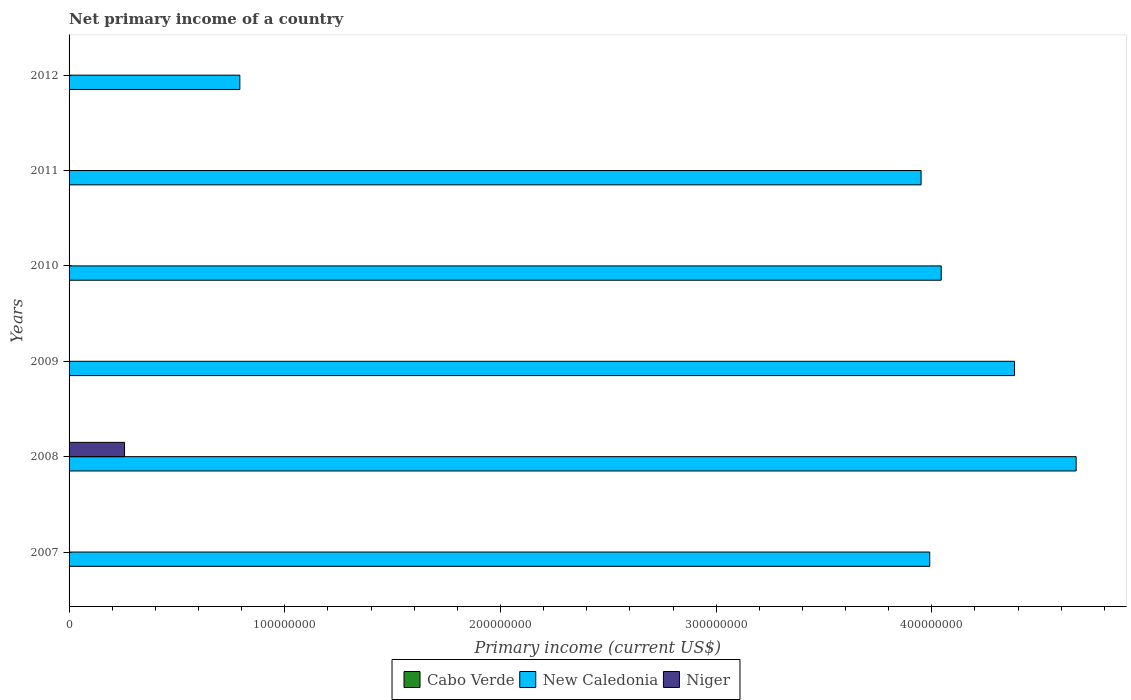Are the number of bars on each tick of the Y-axis equal?
Your response must be concise. No. How many bars are there on the 6th tick from the top?
Offer a terse response. 1. How many bars are there on the 1st tick from the bottom?
Offer a terse response. 1. In how many cases, is the number of bars for a given year not equal to the number of legend labels?
Keep it short and to the point. 6. What is the primary income in New Caledonia in 2012?
Offer a terse response. 7.92e+07. Across all years, what is the maximum primary income in Niger?
Offer a terse response. 2.57e+07. Across all years, what is the minimum primary income in New Caledonia?
Provide a short and direct response. 7.92e+07. What is the total primary income in New Caledonia in the graph?
Make the answer very short. 2.18e+09. What is the difference between the primary income in New Caledonia in 2007 and that in 2010?
Your answer should be very brief. -5.32e+06. What is the difference between the primary income in New Caledonia in 2008 and the primary income in Niger in 2012?
Your response must be concise. 4.67e+08. What is the difference between the highest and the second highest primary income in New Caledonia?
Your answer should be compact. 2.86e+07. What is the difference between the highest and the lowest primary income in New Caledonia?
Make the answer very short. 3.88e+08. Is the sum of the primary income in New Caledonia in 2008 and 2010 greater than the maximum primary income in Cabo Verde across all years?
Make the answer very short. Yes. Are all the bars in the graph horizontal?
Your response must be concise. Yes. Are the values on the major ticks of X-axis written in scientific E-notation?
Your answer should be very brief. No. Does the graph contain grids?
Ensure brevity in your answer.  No. How are the legend labels stacked?
Your answer should be compact. Horizontal. What is the title of the graph?
Provide a short and direct response. Net primary income of a country. What is the label or title of the X-axis?
Your response must be concise. Primary income (current US$). What is the label or title of the Y-axis?
Keep it short and to the point. Years. What is the Primary income (current US$) in New Caledonia in 2007?
Make the answer very short. 3.99e+08. What is the Primary income (current US$) in Niger in 2007?
Offer a terse response. 0. What is the Primary income (current US$) of New Caledonia in 2008?
Provide a short and direct response. 4.67e+08. What is the Primary income (current US$) of Niger in 2008?
Ensure brevity in your answer.  2.57e+07. What is the Primary income (current US$) of Cabo Verde in 2009?
Keep it short and to the point. 0. What is the Primary income (current US$) of New Caledonia in 2009?
Your answer should be compact. 4.38e+08. What is the Primary income (current US$) in Niger in 2009?
Your answer should be very brief. 0. What is the Primary income (current US$) of New Caledonia in 2010?
Keep it short and to the point. 4.04e+08. What is the Primary income (current US$) of Niger in 2010?
Provide a short and direct response. 0. What is the Primary income (current US$) in Cabo Verde in 2011?
Keep it short and to the point. 0. What is the Primary income (current US$) in New Caledonia in 2011?
Provide a short and direct response. 3.95e+08. What is the Primary income (current US$) in Cabo Verde in 2012?
Your response must be concise. 0. What is the Primary income (current US$) of New Caledonia in 2012?
Your answer should be compact. 7.92e+07. What is the Primary income (current US$) in Niger in 2012?
Provide a succinct answer. 0. Across all years, what is the maximum Primary income (current US$) of New Caledonia?
Give a very brief answer. 4.67e+08. Across all years, what is the maximum Primary income (current US$) in Niger?
Ensure brevity in your answer.  2.57e+07. Across all years, what is the minimum Primary income (current US$) in New Caledonia?
Your response must be concise. 7.92e+07. What is the total Primary income (current US$) in New Caledonia in the graph?
Provide a short and direct response. 2.18e+09. What is the total Primary income (current US$) of Niger in the graph?
Provide a succinct answer. 2.57e+07. What is the difference between the Primary income (current US$) in New Caledonia in 2007 and that in 2008?
Offer a terse response. -6.79e+07. What is the difference between the Primary income (current US$) in New Caledonia in 2007 and that in 2009?
Keep it short and to the point. -3.93e+07. What is the difference between the Primary income (current US$) in New Caledonia in 2007 and that in 2010?
Provide a short and direct response. -5.32e+06. What is the difference between the Primary income (current US$) in New Caledonia in 2007 and that in 2011?
Offer a very short reply. 4.02e+06. What is the difference between the Primary income (current US$) in New Caledonia in 2007 and that in 2012?
Your answer should be very brief. 3.20e+08. What is the difference between the Primary income (current US$) of New Caledonia in 2008 and that in 2009?
Your answer should be compact. 2.86e+07. What is the difference between the Primary income (current US$) of New Caledonia in 2008 and that in 2010?
Give a very brief answer. 6.26e+07. What is the difference between the Primary income (current US$) of New Caledonia in 2008 and that in 2011?
Provide a succinct answer. 7.19e+07. What is the difference between the Primary income (current US$) in New Caledonia in 2008 and that in 2012?
Offer a terse response. 3.88e+08. What is the difference between the Primary income (current US$) of New Caledonia in 2009 and that in 2010?
Offer a very short reply. 3.40e+07. What is the difference between the Primary income (current US$) in New Caledonia in 2009 and that in 2011?
Your answer should be very brief. 4.33e+07. What is the difference between the Primary income (current US$) in New Caledonia in 2009 and that in 2012?
Make the answer very short. 3.59e+08. What is the difference between the Primary income (current US$) in New Caledonia in 2010 and that in 2011?
Offer a terse response. 9.33e+06. What is the difference between the Primary income (current US$) in New Caledonia in 2010 and that in 2012?
Make the answer very short. 3.25e+08. What is the difference between the Primary income (current US$) of New Caledonia in 2011 and that in 2012?
Provide a succinct answer. 3.16e+08. What is the difference between the Primary income (current US$) of New Caledonia in 2007 and the Primary income (current US$) of Niger in 2008?
Provide a succinct answer. 3.73e+08. What is the average Primary income (current US$) in Cabo Verde per year?
Provide a short and direct response. 0. What is the average Primary income (current US$) of New Caledonia per year?
Give a very brief answer. 3.64e+08. What is the average Primary income (current US$) of Niger per year?
Make the answer very short. 4.29e+06. In the year 2008, what is the difference between the Primary income (current US$) in New Caledonia and Primary income (current US$) in Niger?
Ensure brevity in your answer.  4.41e+08. What is the ratio of the Primary income (current US$) of New Caledonia in 2007 to that in 2008?
Make the answer very short. 0.85. What is the ratio of the Primary income (current US$) of New Caledonia in 2007 to that in 2009?
Provide a short and direct response. 0.91. What is the ratio of the Primary income (current US$) in New Caledonia in 2007 to that in 2010?
Keep it short and to the point. 0.99. What is the ratio of the Primary income (current US$) of New Caledonia in 2007 to that in 2011?
Offer a very short reply. 1.01. What is the ratio of the Primary income (current US$) of New Caledonia in 2007 to that in 2012?
Ensure brevity in your answer.  5.04. What is the ratio of the Primary income (current US$) of New Caledonia in 2008 to that in 2009?
Give a very brief answer. 1.07. What is the ratio of the Primary income (current US$) in New Caledonia in 2008 to that in 2010?
Give a very brief answer. 1.15. What is the ratio of the Primary income (current US$) of New Caledonia in 2008 to that in 2011?
Make the answer very short. 1.18. What is the ratio of the Primary income (current US$) of New Caledonia in 2008 to that in 2012?
Provide a short and direct response. 5.9. What is the ratio of the Primary income (current US$) of New Caledonia in 2009 to that in 2010?
Keep it short and to the point. 1.08. What is the ratio of the Primary income (current US$) in New Caledonia in 2009 to that in 2011?
Your answer should be very brief. 1.11. What is the ratio of the Primary income (current US$) of New Caledonia in 2009 to that in 2012?
Offer a terse response. 5.54. What is the ratio of the Primary income (current US$) in New Caledonia in 2010 to that in 2011?
Provide a short and direct response. 1.02. What is the ratio of the Primary income (current US$) in New Caledonia in 2010 to that in 2012?
Your answer should be very brief. 5.11. What is the ratio of the Primary income (current US$) of New Caledonia in 2011 to that in 2012?
Your answer should be very brief. 4.99. What is the difference between the highest and the second highest Primary income (current US$) in New Caledonia?
Your response must be concise. 2.86e+07. What is the difference between the highest and the lowest Primary income (current US$) of New Caledonia?
Your response must be concise. 3.88e+08. What is the difference between the highest and the lowest Primary income (current US$) in Niger?
Your answer should be compact. 2.57e+07. 